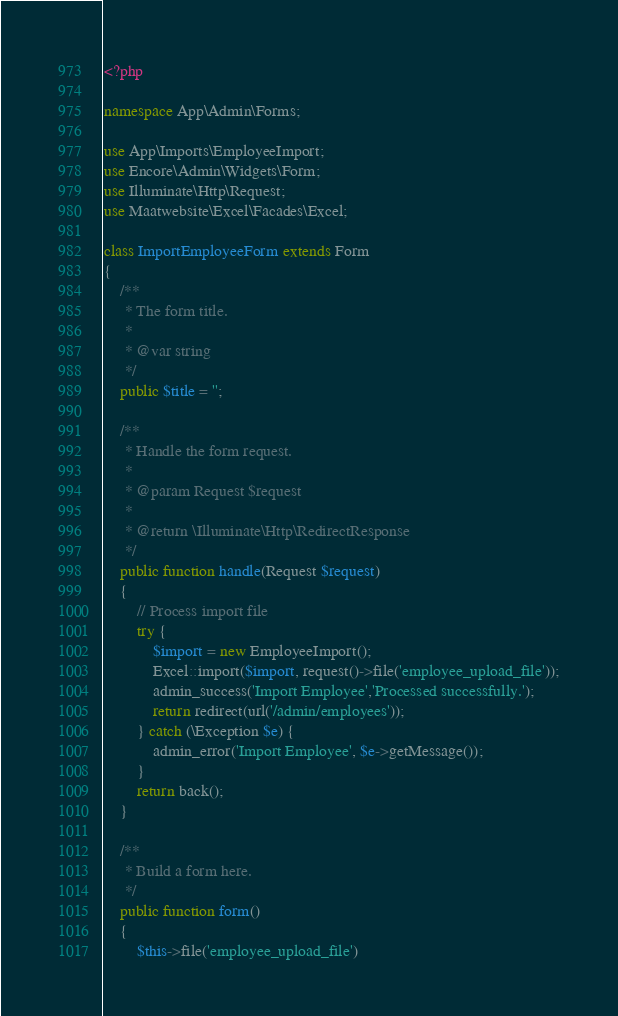<code> <loc_0><loc_0><loc_500><loc_500><_PHP_><?php

namespace App\Admin\Forms;

use App\Imports\EmployeeImport;
use Encore\Admin\Widgets\Form;
use Illuminate\Http\Request;
use Maatwebsite\Excel\Facades\Excel;

class ImportEmployeeForm extends Form
{
    /**
     * The form title.
     *
     * @var string
     */
    public $title = '';

    /**
     * Handle the form request.
     *
     * @param Request $request
     *
     * @return \Illuminate\Http\RedirectResponse
     */
    public function handle(Request $request)
    {
        // Process import file
        try {
            $import = new EmployeeImport();
            Excel::import($import, request()->file('employee_upload_file'));
            admin_success('Import Employee','Processed successfully.');
            return redirect(url('/admin/employees'));
        } catch (\Exception $e) {
            admin_error('Import Employee', $e->getMessage());
        }
        return back();
    }

    /**
     * Build a form here.
     */
    public function form()
    {
        $this->file('employee_upload_file')</code> 